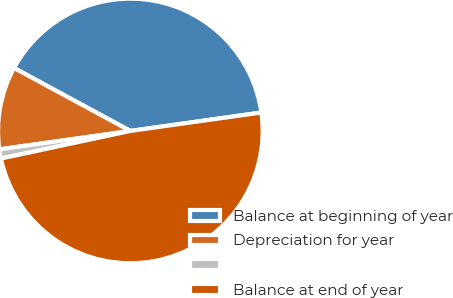Convert chart to OTSL. <chart><loc_0><loc_0><loc_500><loc_500><pie_chart><fcel>Balance at beginning of year<fcel>Depreciation for year<fcel>Unnamed: 2<fcel>Balance at end of year<nl><fcel>39.88%<fcel>10.12%<fcel>1.12%<fcel>48.88%<nl></chart> 